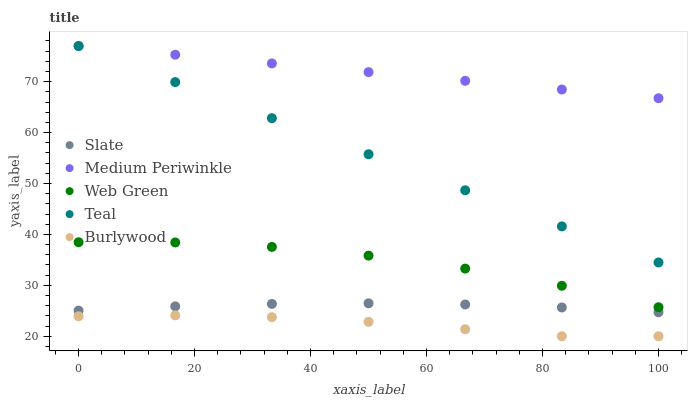Does Burlywood have the minimum area under the curve?
Answer yes or no. Yes. Does Medium Periwinkle have the maximum area under the curve?
Answer yes or no. Yes. Does Slate have the minimum area under the curve?
Answer yes or no. No. Does Slate have the maximum area under the curve?
Answer yes or no. No. Is Medium Periwinkle the smoothest?
Answer yes or no. Yes. Is Web Green the roughest?
Answer yes or no. Yes. Is Slate the smoothest?
Answer yes or no. No. Is Slate the roughest?
Answer yes or no. No. Does Burlywood have the lowest value?
Answer yes or no. Yes. Does Slate have the lowest value?
Answer yes or no. No. Does Teal have the highest value?
Answer yes or no. Yes. Does Slate have the highest value?
Answer yes or no. No. Is Burlywood less than Medium Periwinkle?
Answer yes or no. Yes. Is Medium Periwinkle greater than Web Green?
Answer yes or no. Yes. Does Medium Periwinkle intersect Teal?
Answer yes or no. Yes. Is Medium Periwinkle less than Teal?
Answer yes or no. No. Is Medium Periwinkle greater than Teal?
Answer yes or no. No. Does Burlywood intersect Medium Periwinkle?
Answer yes or no. No. 